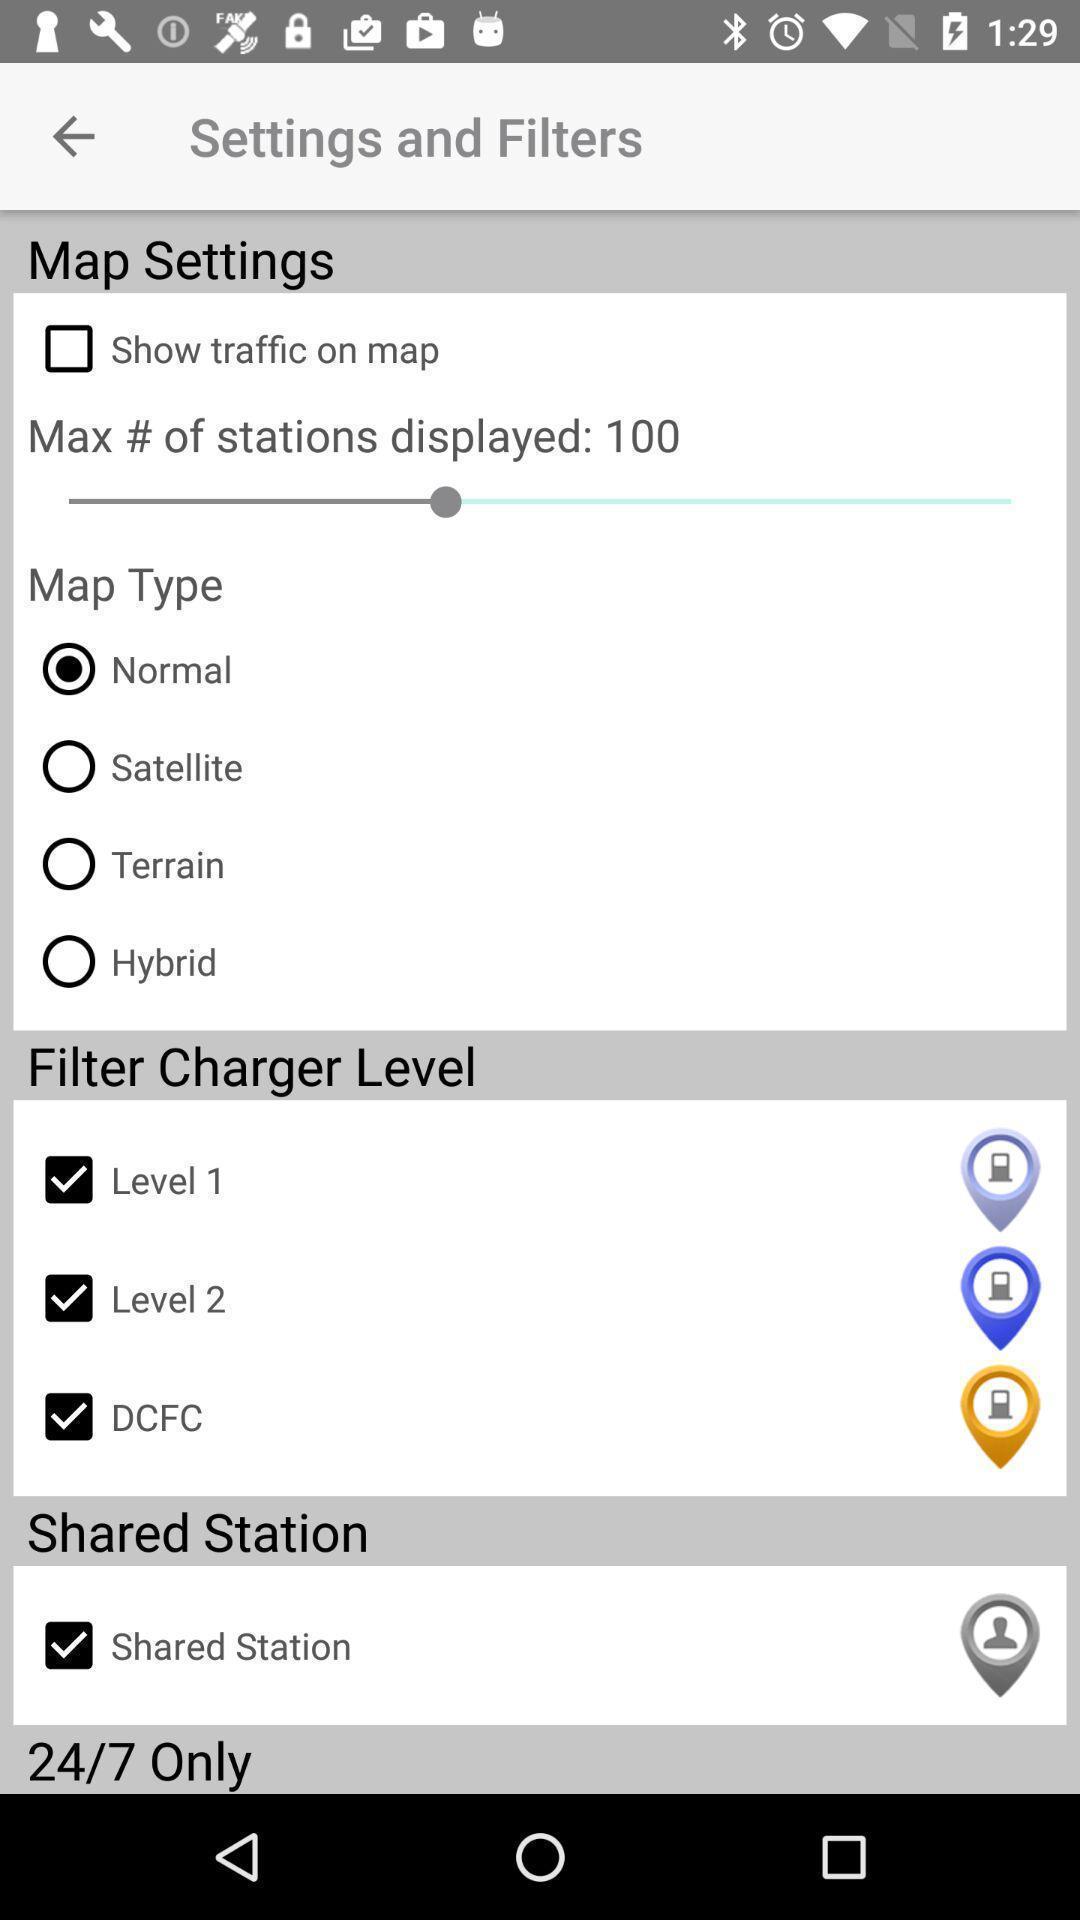Describe the content in this image. Page showing variety of settings. 